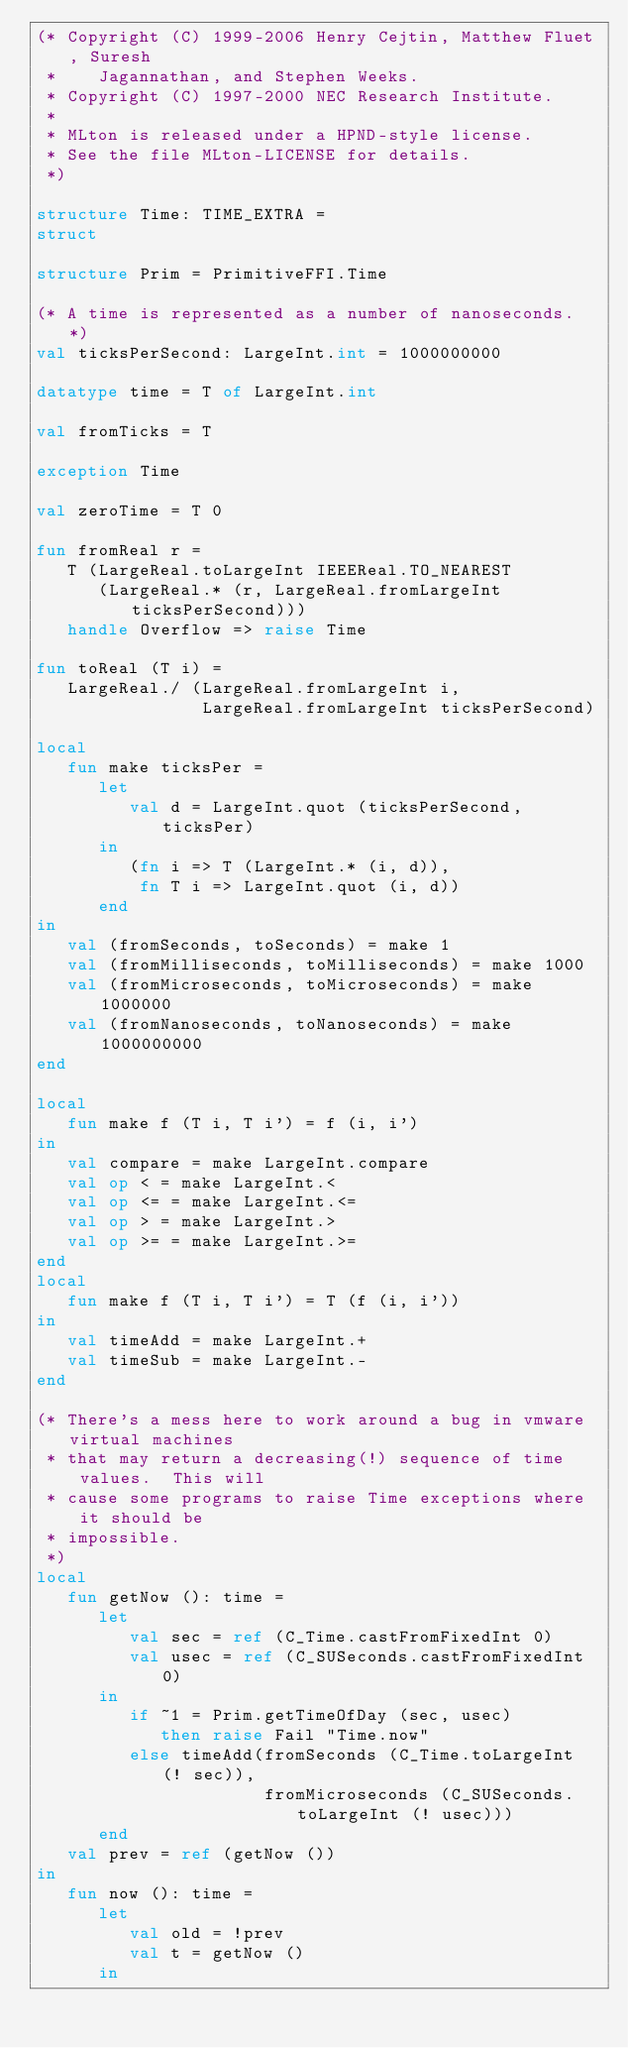Convert code to text. <code><loc_0><loc_0><loc_500><loc_500><_SML_>(* Copyright (C) 1999-2006 Henry Cejtin, Matthew Fluet, Suresh
 *    Jagannathan, and Stephen Weeks.
 * Copyright (C) 1997-2000 NEC Research Institute.
 *
 * MLton is released under a HPND-style license.
 * See the file MLton-LICENSE for details.
 *)

structure Time: TIME_EXTRA =
struct

structure Prim = PrimitiveFFI.Time

(* A time is represented as a number of nanoseconds. *)
val ticksPerSecond: LargeInt.int = 1000000000

datatype time = T of LargeInt.int

val fromTicks = T

exception Time

val zeroTime = T 0

fun fromReal r =
   T (LargeReal.toLargeInt IEEEReal.TO_NEAREST 
      (LargeReal.* (r, LargeReal.fromLargeInt ticksPerSecond)))
   handle Overflow => raise Time

fun toReal (T i) =
   LargeReal./ (LargeReal.fromLargeInt i, 
                LargeReal.fromLargeInt ticksPerSecond)

local
   fun make ticksPer =
      let
         val d = LargeInt.quot (ticksPerSecond, ticksPer)
      in
         (fn i => T (LargeInt.* (i, d)),
          fn T i => LargeInt.quot (i, d))
      end
in
   val (fromSeconds, toSeconds) = make 1
   val (fromMilliseconds, toMilliseconds) = make 1000
   val (fromMicroseconds, toMicroseconds) = make 1000000
   val (fromNanoseconds, toNanoseconds) = make 1000000000
end

local
   fun make f (T i, T i') = f (i, i')
in
   val compare = make LargeInt.compare
   val op < = make LargeInt.<
   val op <= = make LargeInt.<=
   val op > = make LargeInt.>
   val op >= = make LargeInt.>=
end
local
   fun make f (T i, T i') = T (f (i, i'))
in
   val timeAdd = make LargeInt.+
   val timeSub = make LargeInt.-
end

(* There's a mess here to work around a bug in vmware virtual machines
 * that may return a decreasing(!) sequence of time values.  This will
 * cause some programs to raise Time exceptions where it should be
 * impossible.
 *)
local
   fun getNow (): time =
      let
         val sec = ref (C_Time.castFromFixedInt 0)
         val usec = ref (C_SUSeconds.castFromFixedInt 0)
      in
         if ~1 = Prim.getTimeOfDay (sec, usec)
            then raise Fail "Time.now"
         else timeAdd(fromSeconds (C_Time.toLargeInt (! sec)),
                      fromMicroseconds (C_SUSeconds.toLargeInt (! usec)))
      end
   val prev = ref (getNow ())
in
   fun now (): time =
      let
         val old = !prev
         val t = getNow ()
      in</code> 